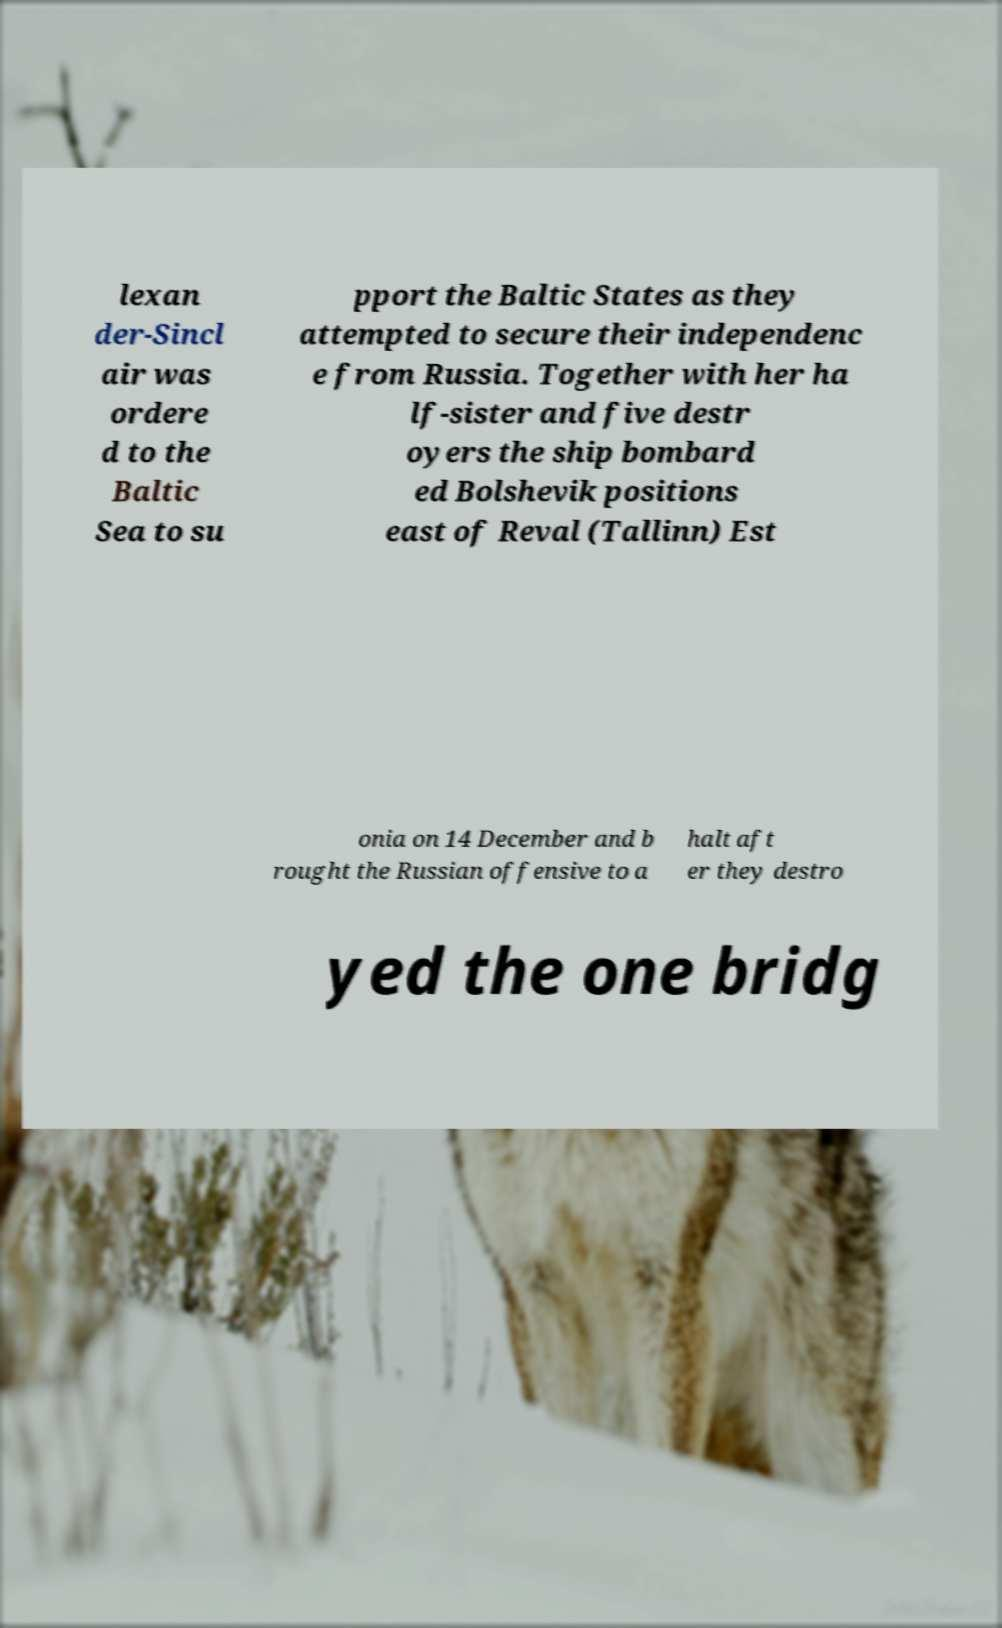I need the written content from this picture converted into text. Can you do that? lexan der-Sincl air was ordere d to the Baltic Sea to su pport the Baltic States as they attempted to secure their independenc e from Russia. Together with her ha lf-sister and five destr oyers the ship bombard ed Bolshevik positions east of Reval (Tallinn) Est onia on 14 December and b rought the Russian offensive to a halt aft er they destro yed the one bridg 